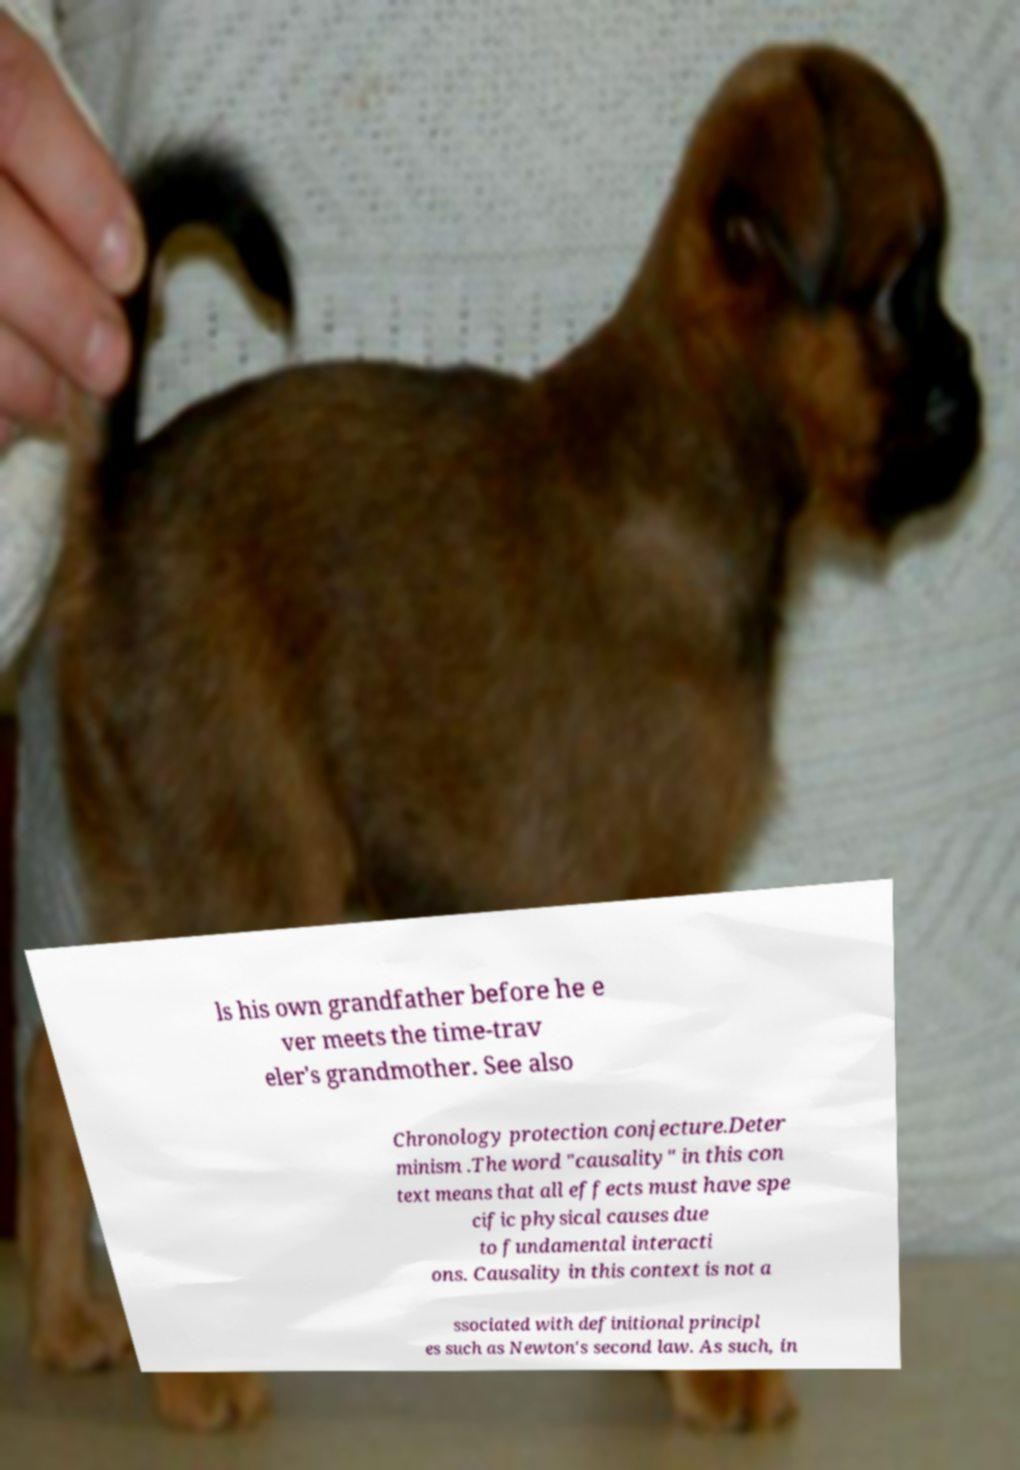I need the written content from this picture converted into text. Can you do that? ls his own grandfather before he e ver meets the time-trav eler's grandmother. See also Chronology protection conjecture.Deter minism .The word "causality" in this con text means that all effects must have spe cific physical causes due to fundamental interacti ons. Causality in this context is not a ssociated with definitional principl es such as Newton's second law. As such, in 